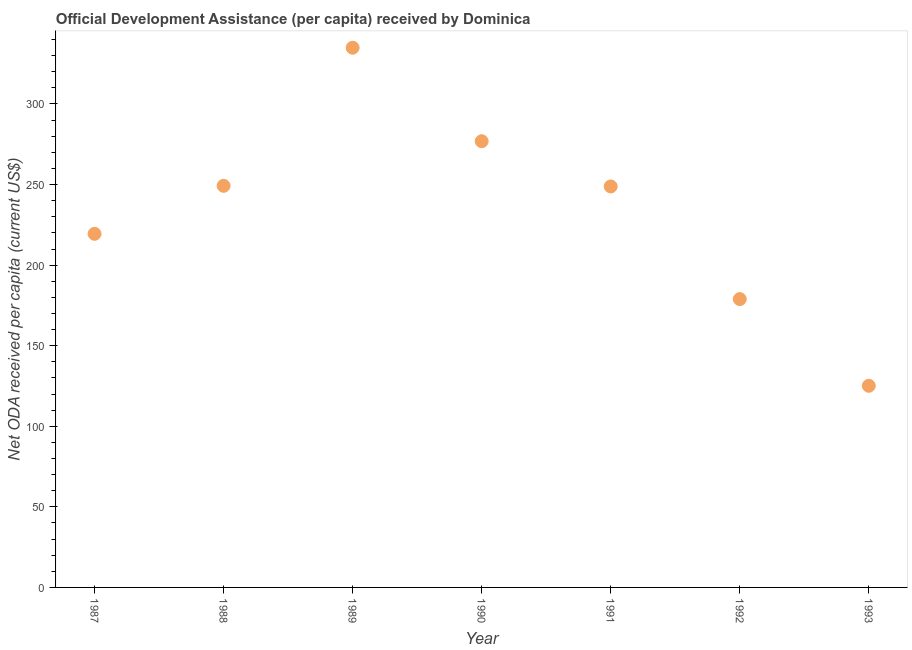What is the net oda received per capita in 1989?
Your answer should be very brief. 334.91. Across all years, what is the maximum net oda received per capita?
Ensure brevity in your answer.  334.91. Across all years, what is the minimum net oda received per capita?
Provide a succinct answer. 125.13. In which year was the net oda received per capita maximum?
Provide a short and direct response. 1989. What is the sum of the net oda received per capita?
Offer a very short reply. 1633.37. What is the difference between the net oda received per capita in 1988 and 1992?
Your response must be concise. 70.29. What is the average net oda received per capita per year?
Provide a succinct answer. 233.34. What is the median net oda received per capita?
Keep it short and to the point. 248.84. What is the ratio of the net oda received per capita in 1990 to that in 1993?
Your response must be concise. 2.21. What is the difference between the highest and the second highest net oda received per capita?
Make the answer very short. 58.01. What is the difference between the highest and the lowest net oda received per capita?
Offer a terse response. 209.78. Does the net oda received per capita monotonically increase over the years?
Offer a very short reply. No. How many dotlines are there?
Keep it short and to the point. 1. How many years are there in the graph?
Provide a succinct answer. 7. What is the title of the graph?
Your response must be concise. Official Development Assistance (per capita) received by Dominica. What is the label or title of the X-axis?
Keep it short and to the point. Year. What is the label or title of the Y-axis?
Provide a succinct answer. Net ODA received per capita (current US$). What is the Net ODA received per capita (current US$) in 1987?
Your answer should be very brief. 219.43. What is the Net ODA received per capita (current US$) in 1988?
Give a very brief answer. 249.22. What is the Net ODA received per capita (current US$) in 1989?
Keep it short and to the point. 334.91. What is the Net ODA received per capita (current US$) in 1990?
Provide a short and direct response. 276.9. What is the Net ODA received per capita (current US$) in 1991?
Offer a terse response. 248.84. What is the Net ODA received per capita (current US$) in 1992?
Offer a very short reply. 178.93. What is the Net ODA received per capita (current US$) in 1993?
Make the answer very short. 125.13. What is the difference between the Net ODA received per capita (current US$) in 1987 and 1988?
Provide a succinct answer. -29.79. What is the difference between the Net ODA received per capita (current US$) in 1987 and 1989?
Make the answer very short. -115.48. What is the difference between the Net ODA received per capita (current US$) in 1987 and 1990?
Your answer should be very brief. -57.47. What is the difference between the Net ODA received per capita (current US$) in 1987 and 1991?
Your response must be concise. -29.41. What is the difference between the Net ODA received per capita (current US$) in 1987 and 1992?
Offer a terse response. 40.51. What is the difference between the Net ODA received per capita (current US$) in 1987 and 1993?
Provide a succinct answer. 94.3. What is the difference between the Net ODA received per capita (current US$) in 1988 and 1989?
Give a very brief answer. -85.69. What is the difference between the Net ODA received per capita (current US$) in 1988 and 1990?
Make the answer very short. -27.68. What is the difference between the Net ODA received per capita (current US$) in 1988 and 1991?
Provide a short and direct response. 0.38. What is the difference between the Net ODA received per capita (current US$) in 1988 and 1992?
Offer a terse response. 70.29. What is the difference between the Net ODA received per capita (current US$) in 1988 and 1993?
Ensure brevity in your answer.  124.09. What is the difference between the Net ODA received per capita (current US$) in 1989 and 1990?
Provide a succinct answer. 58.01. What is the difference between the Net ODA received per capita (current US$) in 1989 and 1991?
Provide a succinct answer. 86.08. What is the difference between the Net ODA received per capita (current US$) in 1989 and 1992?
Your answer should be compact. 155.99. What is the difference between the Net ODA received per capita (current US$) in 1989 and 1993?
Provide a succinct answer. 209.78. What is the difference between the Net ODA received per capita (current US$) in 1990 and 1991?
Your answer should be very brief. 28.06. What is the difference between the Net ODA received per capita (current US$) in 1990 and 1992?
Offer a very short reply. 97.97. What is the difference between the Net ODA received per capita (current US$) in 1990 and 1993?
Your answer should be compact. 151.77. What is the difference between the Net ODA received per capita (current US$) in 1991 and 1992?
Offer a very short reply. 69.91. What is the difference between the Net ODA received per capita (current US$) in 1991 and 1993?
Provide a short and direct response. 123.71. What is the difference between the Net ODA received per capita (current US$) in 1992 and 1993?
Your answer should be compact. 53.8. What is the ratio of the Net ODA received per capita (current US$) in 1987 to that in 1989?
Ensure brevity in your answer.  0.66. What is the ratio of the Net ODA received per capita (current US$) in 1987 to that in 1990?
Provide a succinct answer. 0.79. What is the ratio of the Net ODA received per capita (current US$) in 1987 to that in 1991?
Ensure brevity in your answer.  0.88. What is the ratio of the Net ODA received per capita (current US$) in 1987 to that in 1992?
Give a very brief answer. 1.23. What is the ratio of the Net ODA received per capita (current US$) in 1987 to that in 1993?
Make the answer very short. 1.75. What is the ratio of the Net ODA received per capita (current US$) in 1988 to that in 1989?
Provide a short and direct response. 0.74. What is the ratio of the Net ODA received per capita (current US$) in 1988 to that in 1991?
Keep it short and to the point. 1. What is the ratio of the Net ODA received per capita (current US$) in 1988 to that in 1992?
Your answer should be compact. 1.39. What is the ratio of the Net ODA received per capita (current US$) in 1988 to that in 1993?
Your answer should be very brief. 1.99. What is the ratio of the Net ODA received per capita (current US$) in 1989 to that in 1990?
Your answer should be very brief. 1.21. What is the ratio of the Net ODA received per capita (current US$) in 1989 to that in 1991?
Your answer should be compact. 1.35. What is the ratio of the Net ODA received per capita (current US$) in 1989 to that in 1992?
Your answer should be compact. 1.87. What is the ratio of the Net ODA received per capita (current US$) in 1989 to that in 1993?
Your answer should be compact. 2.68. What is the ratio of the Net ODA received per capita (current US$) in 1990 to that in 1991?
Offer a very short reply. 1.11. What is the ratio of the Net ODA received per capita (current US$) in 1990 to that in 1992?
Offer a very short reply. 1.55. What is the ratio of the Net ODA received per capita (current US$) in 1990 to that in 1993?
Your answer should be compact. 2.21. What is the ratio of the Net ODA received per capita (current US$) in 1991 to that in 1992?
Make the answer very short. 1.39. What is the ratio of the Net ODA received per capita (current US$) in 1991 to that in 1993?
Provide a short and direct response. 1.99. What is the ratio of the Net ODA received per capita (current US$) in 1992 to that in 1993?
Give a very brief answer. 1.43. 